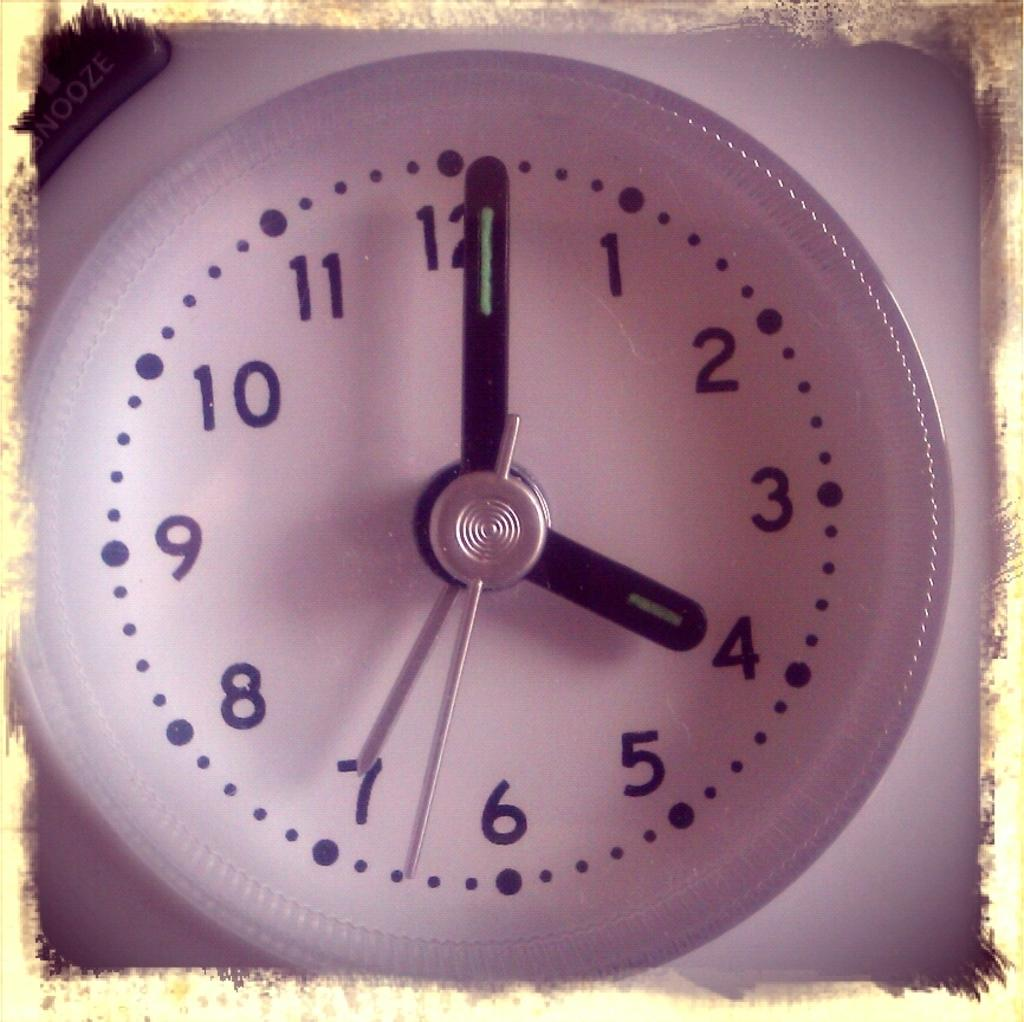<image>
Create a compact narrative representing the image presented. A pink clock shows the time at "4:01." 